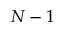Convert formula to latex. <formula><loc_0><loc_0><loc_500><loc_500>N - 1</formula> 